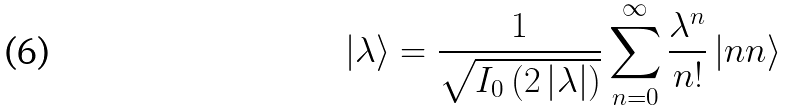<formula> <loc_0><loc_0><loc_500><loc_500>\left | \lambda \right \rangle = \frac { 1 } { \sqrt { I _ { 0 } \left ( 2 \left | \lambda \right | \right ) } } \sum _ { n = 0 } ^ { \infty } { \frac { \lambda ^ { n } } { n ! } \left | { n n } \right \rangle }</formula> 